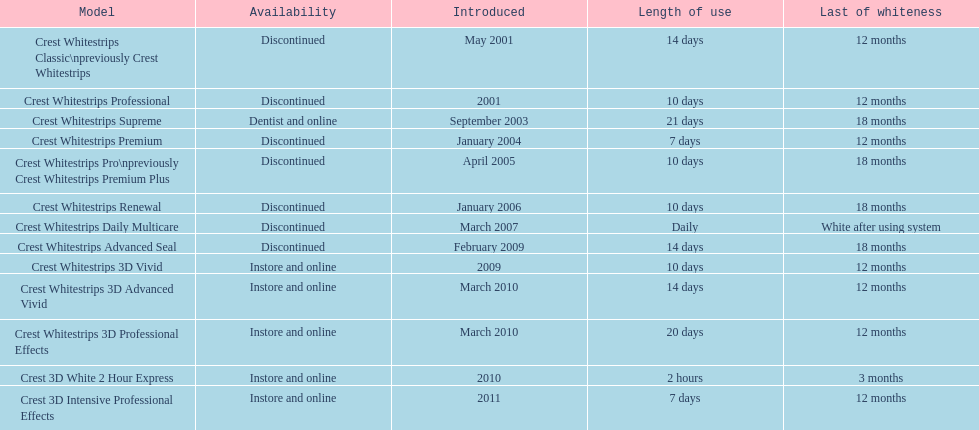Crest 3d intensive professional effects and crest whitestrips 3d professional effects both have a lasting whiteness of how many months? 12 months. 